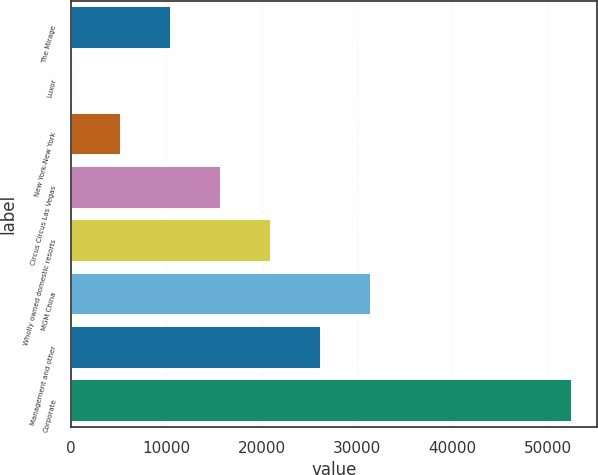Convert chart. <chart><loc_0><loc_0><loc_500><loc_500><bar_chart><fcel>The Mirage<fcel>Luxor<fcel>New York-New York<fcel>Circus Circus Las Vegas<fcel>Wholly owned domestic resorts<fcel>MGM China<fcel>Management and other<fcel>Corporate<nl><fcel>10499.8<fcel>2<fcel>5250.9<fcel>15748.7<fcel>20997.6<fcel>31495.4<fcel>26246.5<fcel>52491<nl></chart> 